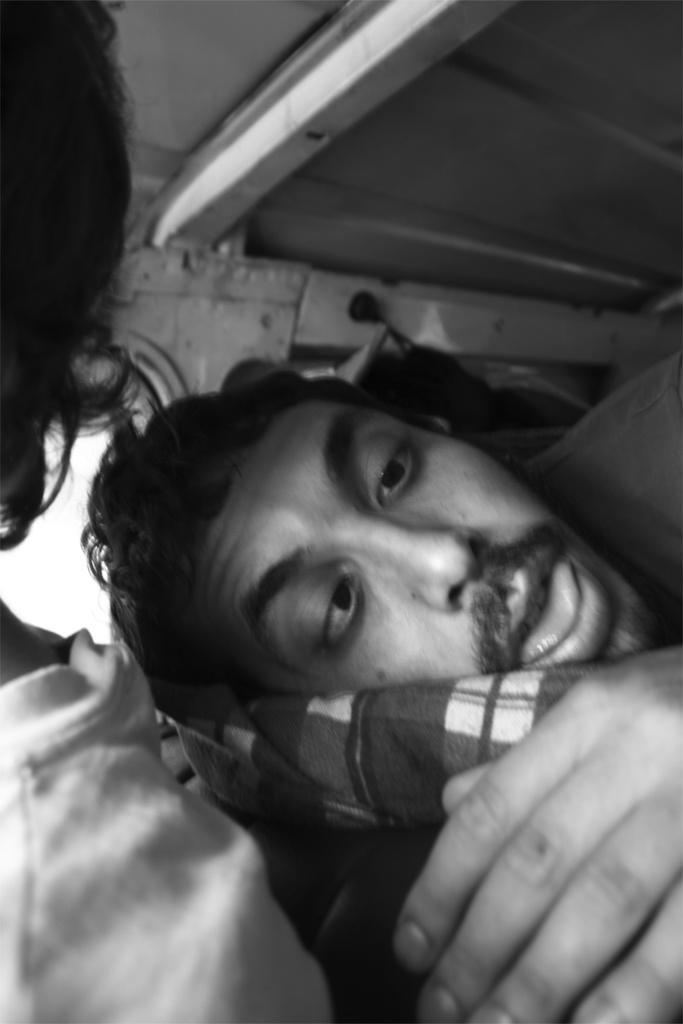In one or two sentences, can you explain what this image depicts? In this picture I can see couple of humans and looks like a wall in the background. 